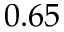Convert formula to latex. <formula><loc_0><loc_0><loc_500><loc_500>0 . 6 5</formula> 